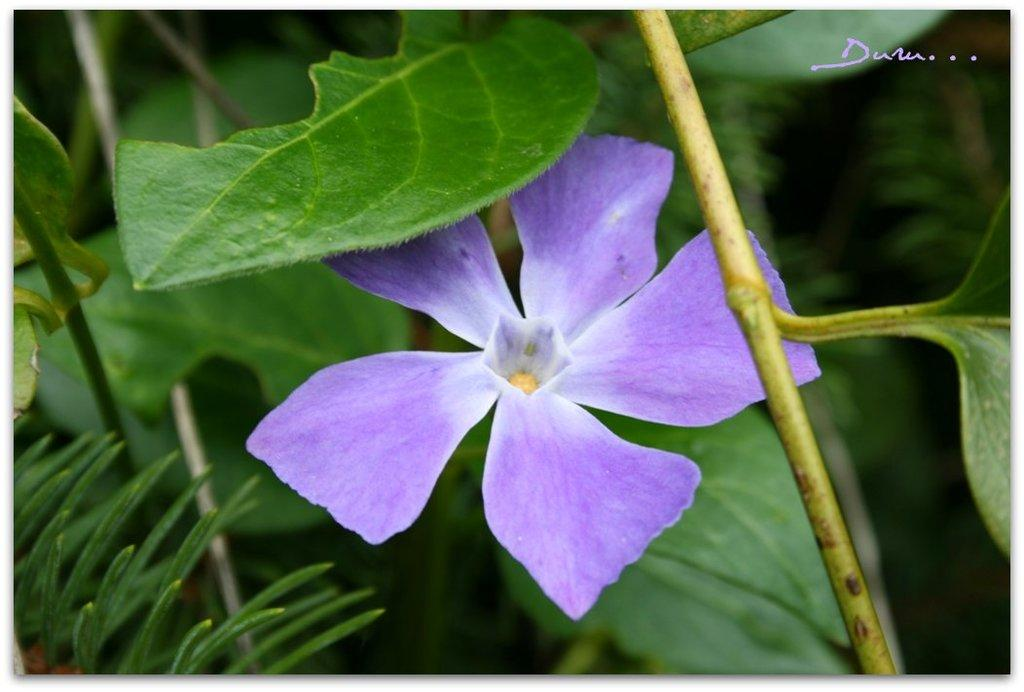What is the main subject of the image? There is a purple flower in the center of the image. What else can be seen in the image besides the flower? There are plants around the area of the image. What type of representative is present in the image? There is no representative present in the image; it features a purple flower and plants. Can you see a kitty wearing a scarf in the image? There is no kitty or scarf present in the image. 